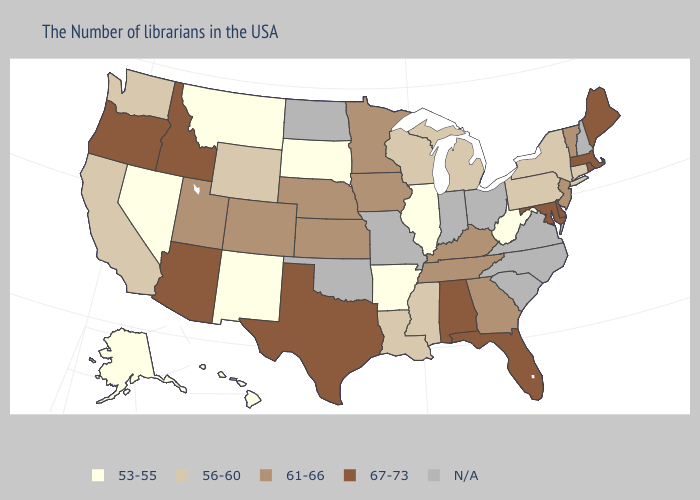Name the states that have a value in the range N/A?
Give a very brief answer. New Hampshire, Virginia, North Carolina, South Carolina, Ohio, Indiana, Missouri, Oklahoma, North Dakota. Name the states that have a value in the range 67-73?
Answer briefly. Maine, Massachusetts, Rhode Island, Delaware, Maryland, Florida, Alabama, Texas, Arizona, Idaho, Oregon. Which states have the lowest value in the South?
Give a very brief answer. West Virginia, Arkansas. Is the legend a continuous bar?
Write a very short answer. No. What is the value of South Dakota?
Write a very short answer. 53-55. Name the states that have a value in the range N/A?
Short answer required. New Hampshire, Virginia, North Carolina, South Carolina, Ohio, Indiana, Missouri, Oklahoma, North Dakota. Does Kentucky have the lowest value in the South?
Give a very brief answer. No. Name the states that have a value in the range 61-66?
Answer briefly. Vermont, New Jersey, Georgia, Kentucky, Tennessee, Minnesota, Iowa, Kansas, Nebraska, Colorado, Utah. Does Rhode Island have the highest value in the Northeast?
Short answer required. Yes. Among the states that border Nebraska , does Colorado have the lowest value?
Be succinct. No. Does Vermont have the highest value in the Northeast?
Quick response, please. No. What is the value of Mississippi?
Answer briefly. 56-60. Name the states that have a value in the range 53-55?
Be succinct. West Virginia, Illinois, Arkansas, South Dakota, New Mexico, Montana, Nevada, Alaska, Hawaii. Among the states that border Kentucky , does Illinois have the highest value?
Short answer required. No. 